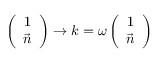Convert formula to latex. <formula><loc_0><loc_0><loc_500><loc_500>\left ( \begin{array} { c } { 1 } \\ { { \vec { n } } } \end{array} \right ) \rightarrow k = \omega \left ( \begin{array} { c } { 1 } \\ { { \vec { n } } } \end{array} \right )</formula> 